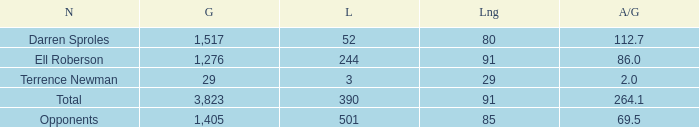When the Gain is 29, and the average per game is 2, and the player lost less than 390 yards, what's the sum of the Long yards? None. 